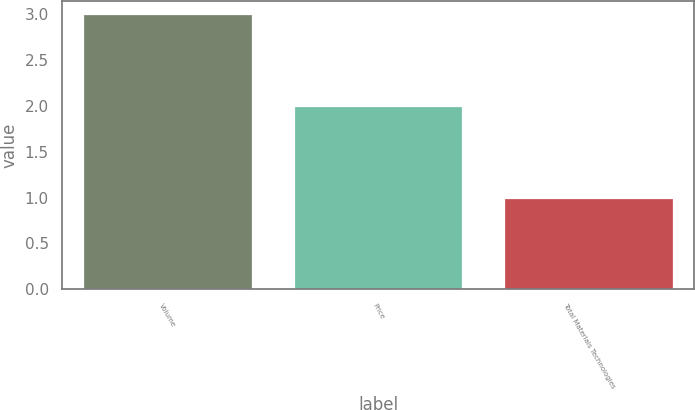Convert chart. <chart><loc_0><loc_0><loc_500><loc_500><bar_chart><fcel>Volume<fcel>Price<fcel>Total Materials Technologies<nl><fcel>3<fcel>2<fcel>1<nl></chart> 